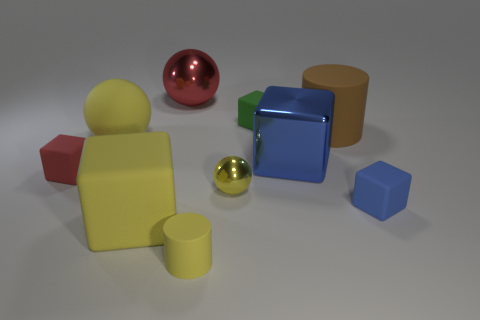Subtract all green cubes. How many cubes are left? 4 Subtract all yellow cubes. How many cubes are left? 4 Subtract all gray cubes. Subtract all gray spheres. How many cubes are left? 5 Subtract all spheres. How many objects are left? 7 Add 1 green matte objects. How many green matte objects exist? 2 Subtract 1 green cubes. How many objects are left? 9 Subtract all small yellow things. Subtract all large yellow matte cubes. How many objects are left? 7 Add 8 shiny cubes. How many shiny cubes are left? 9 